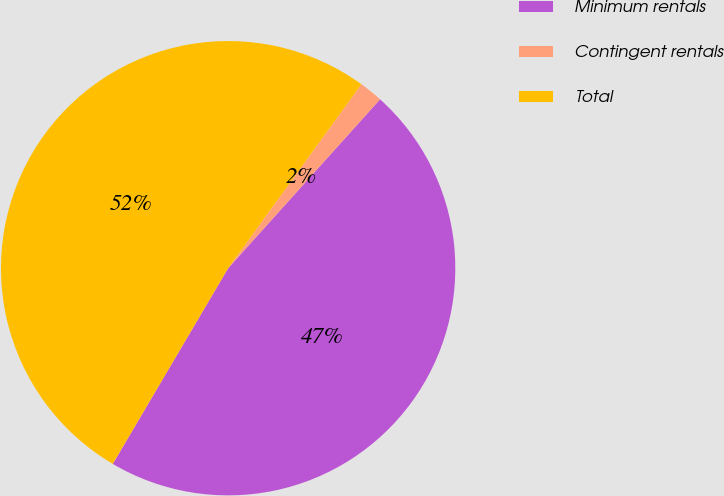Convert chart to OTSL. <chart><loc_0><loc_0><loc_500><loc_500><pie_chart><fcel>Minimum rentals<fcel>Contingent rentals<fcel>Total<nl><fcel>46.82%<fcel>1.68%<fcel>51.5%<nl></chart> 